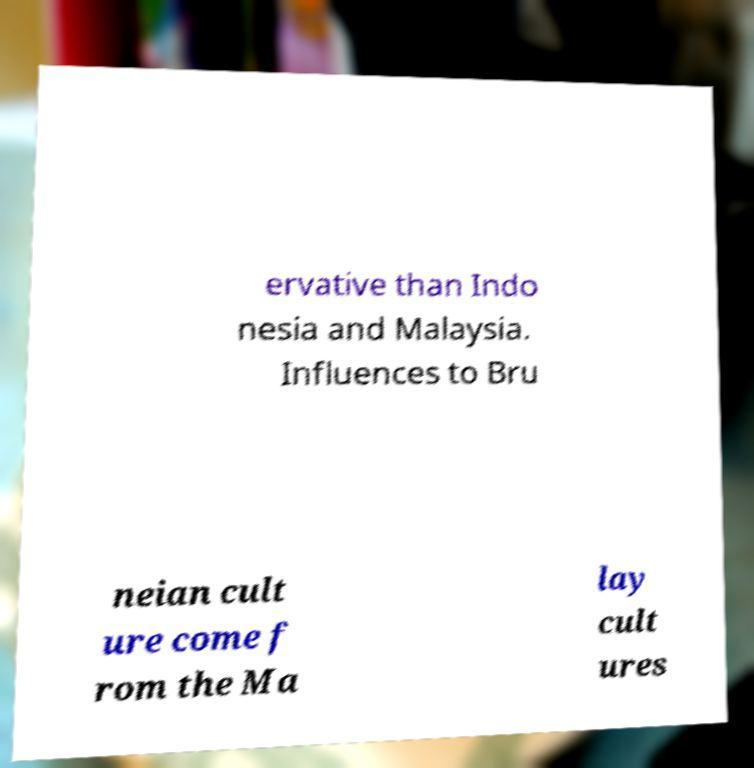For documentation purposes, I need the text within this image transcribed. Could you provide that? ervative than Indo nesia and Malaysia. Influences to Bru neian cult ure come f rom the Ma lay cult ures 